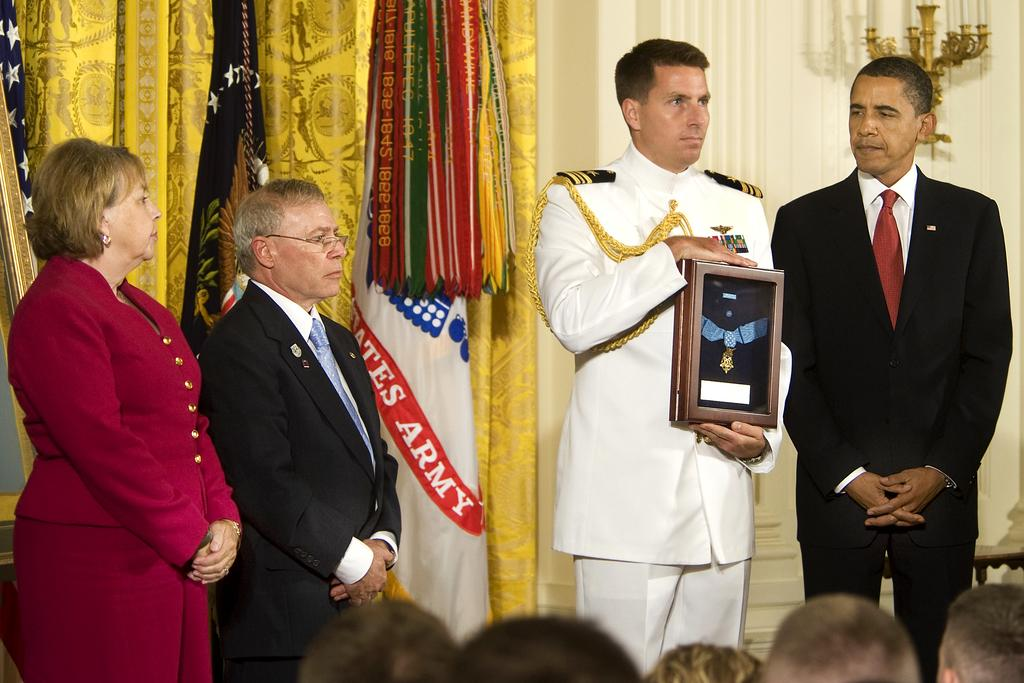<image>
Create a compact narrative representing the image presented. a few people posing with an Army flag behind them 